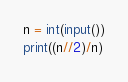<code> <loc_0><loc_0><loc_500><loc_500><_Python_>n = int(input())
print((n//2)/n)</code> 